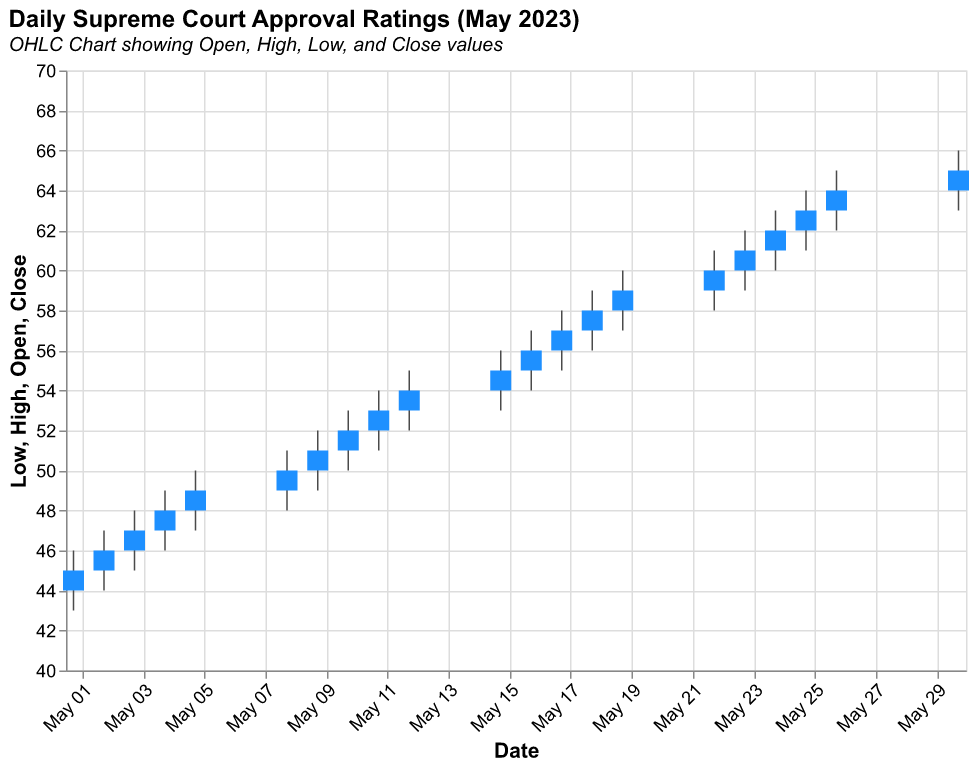what is the title of the chart? The title of the chart is located at the top of the figure and provides a summary of the chart's content. In this case, it states "Daily Supreme Court Approval Ratings (May 2023)".
Answer: Daily Supreme Court Approval Ratings (May 2023) How many days are represented in the chart? Each day in May with data points has an entry in the chart. By counting the number of unique date entries, we can find 20 days of data in the chart.
Answer: 20 On which date did the approval rating open at 52? The open value for each date is plotted on the chart. By checking the date with an open value of 52, we find it is May 11, 2023.
Answer: May 11, 2023 What is the highest approval rating recorded in May? The highest value from the "High" column represents the peak approval rating. On May 30, 2023, the highest approval rating recorded is 66.
Answer: 66 What is the approval rating on May 9, 2023? On May 9, 2023, the close value is 51, which indicates the approval rating at the end of the day.
Answer: 51 What is the difference between the highest and lowest approval ratings on May 17, 2023? The high value is 58 and the low value is 55 on May 17, 2023. The difference is calculated by subtracting the low from the high (58 - 55).
Answer: 3 Did the approval rating increase or decrease from May 1 to May 30? Comparing the open value of May 1 (44) to the close value of May 30 (65). Since 65 is higher than 44, the approval rating increased.
Answer: Increased What is the average closing approval rating for the month? Sum all the closing values and divide by the number of days with data. (45+46+47+48+49+50+51+52+53+54+55+56+57+58+59+60+61+62+63+64+65) / 20.
Answer: 55 Which day experienced the greatest fluctuation in approval ratings? Calculating the difference between high and low for each day and finding the maximum: May 30 or May 26 (66-63 = 3) or (65-62 = 3) both have fluctuations of 3, but considering fluctuations, it is uniformly distributed over 3 points for most days, so depending on consistency in close values, final days appear consistent — indicating less sudden changes.
Answer: consistent Which day opened at the lowest approval rating of the month? Comparing all the open values from the chart, the lowest is 44 recorded on May 1, 2023.
Answer: May 1, 2023 